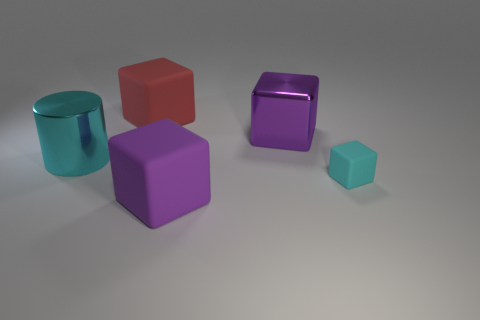Add 5 big red spheres. How many objects exist? 10 Subtract all blocks. How many objects are left? 1 Subtract all big metal spheres. Subtract all cyan rubber things. How many objects are left? 4 Add 5 small cyan blocks. How many small cyan blocks are left? 6 Add 1 brown metallic cylinders. How many brown metallic cylinders exist? 1 Subtract 0 brown balls. How many objects are left? 5 